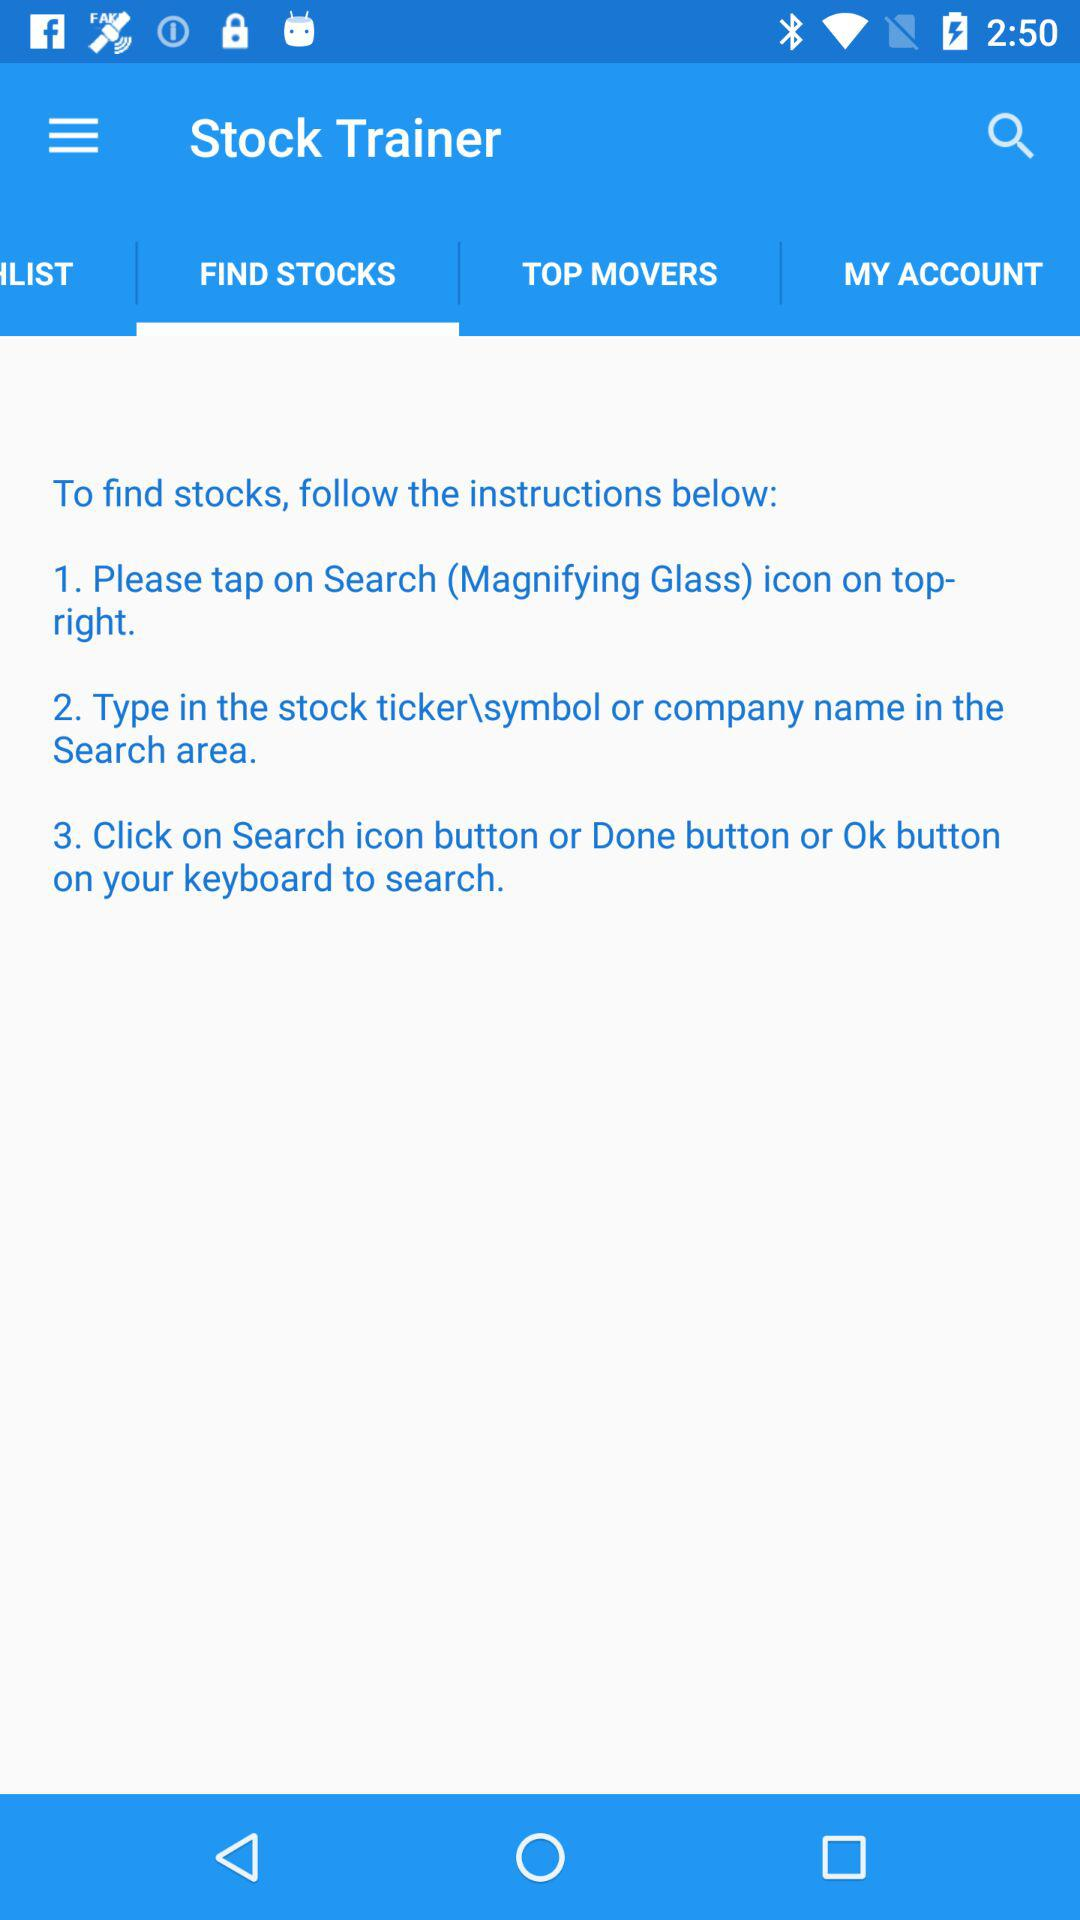What are the instructions to find stocks in the stock trainer?
Answer the question using a single word or phrase. The instructions to find stocks are: "1. Please tap on Search (Magnifying Glass) icon on top-right. 2. Type in the stock ticker\symbol or company name in the Search area. 3. Click on Search icon button or Done button or Ok button on your keyboard to search." 